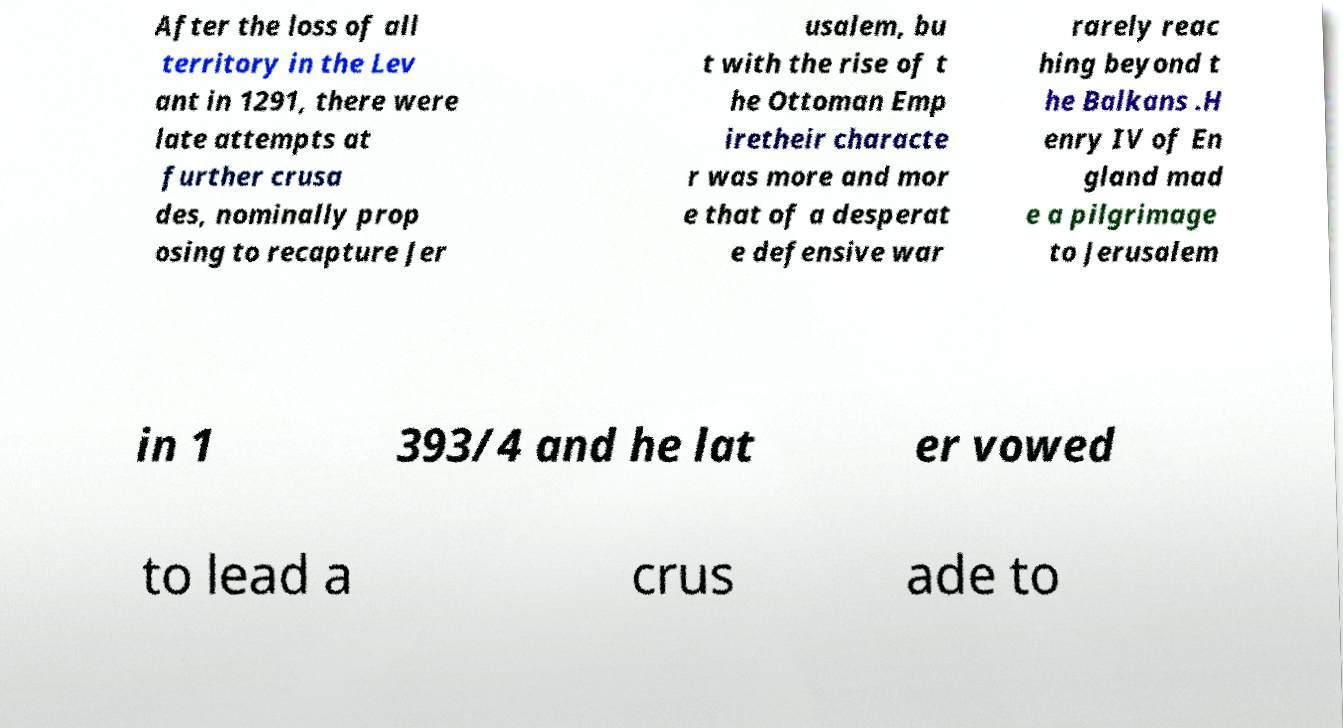What messages or text are displayed in this image? I need them in a readable, typed format. After the loss of all territory in the Lev ant in 1291, there were late attempts at further crusa des, nominally prop osing to recapture Jer usalem, bu t with the rise of t he Ottoman Emp iretheir characte r was more and mor e that of a desperat e defensive war rarely reac hing beyond t he Balkans .H enry IV of En gland mad e a pilgrimage to Jerusalem in 1 393/4 and he lat er vowed to lead a crus ade to 